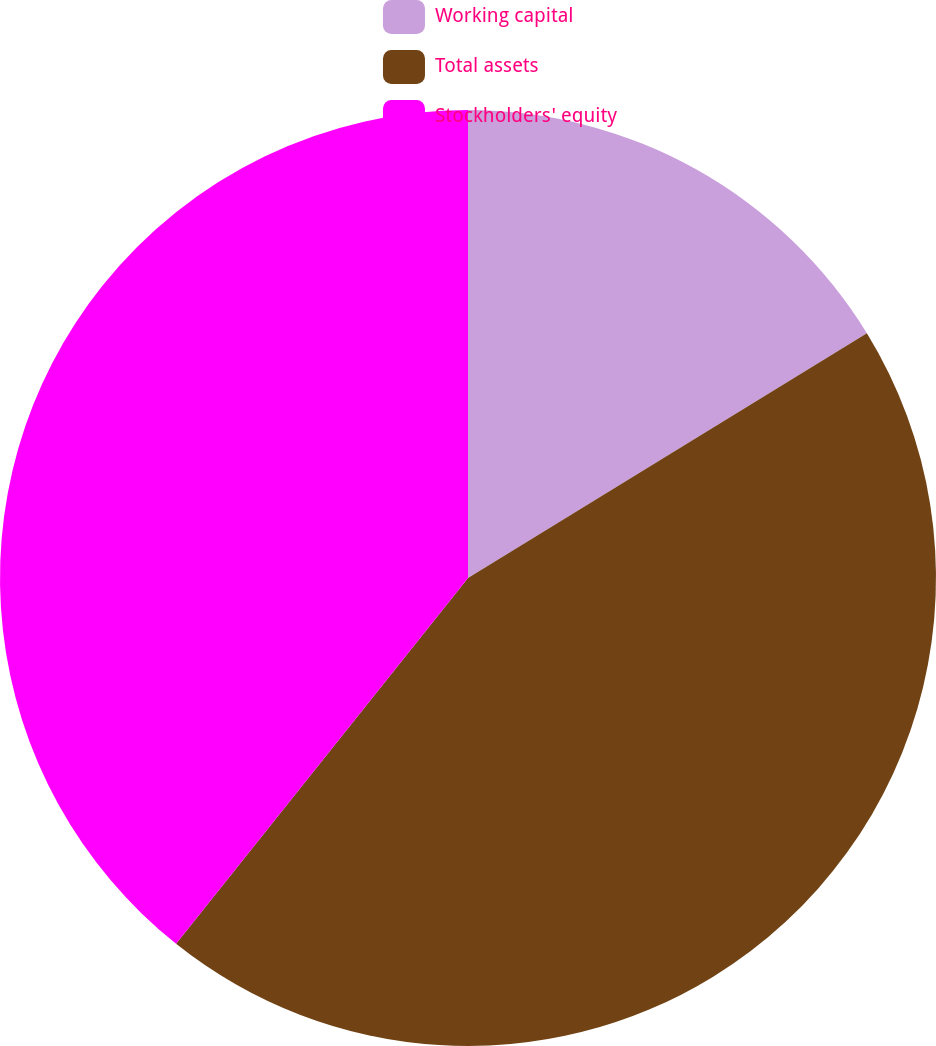<chart> <loc_0><loc_0><loc_500><loc_500><pie_chart><fcel>Working capital<fcel>Total assets<fcel>Stockholders' equity<nl><fcel>16.24%<fcel>44.48%<fcel>39.28%<nl></chart> 